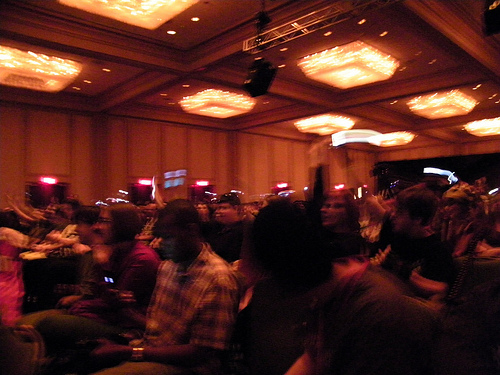<image>
Can you confirm if the man is under the light? Yes. The man is positioned underneath the light, with the light above it in the vertical space. Is there a light above the head? Yes. The light is positioned above the head in the vertical space, higher up in the scene. 